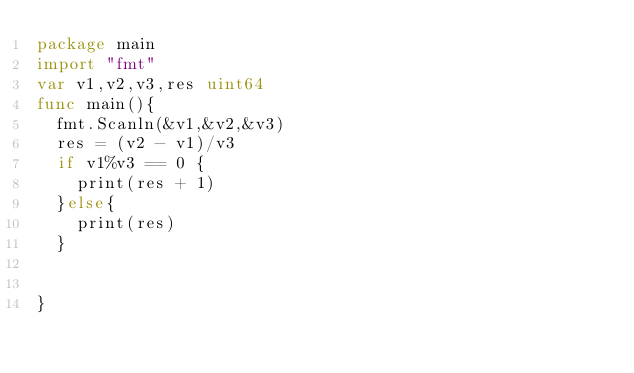<code> <loc_0><loc_0><loc_500><loc_500><_Go_>package main
import "fmt"
var v1,v2,v3,res uint64
func main(){
  fmt.Scanln(&v1,&v2,&v3)
  res = (v2 - v1)/v3
  if v1%v3 == 0 {
    print(res + 1)
  }else{
    print(res)
  }
  
  
}
</code> 